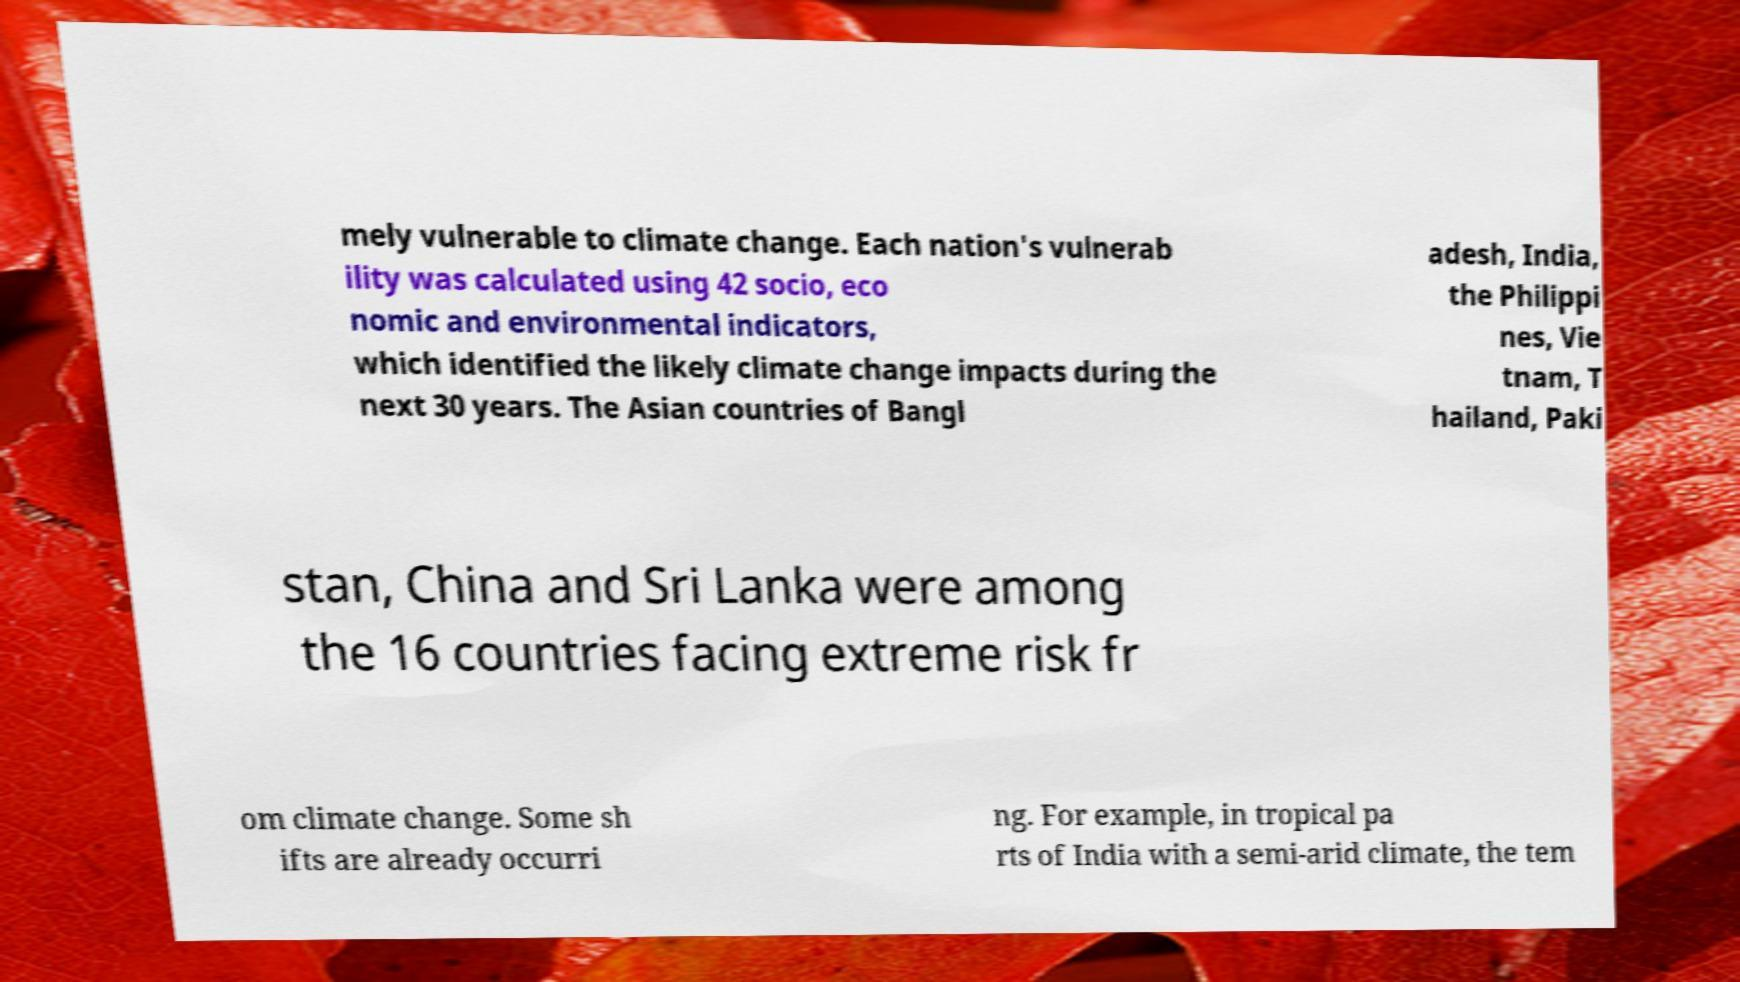For documentation purposes, I need the text within this image transcribed. Could you provide that? mely vulnerable to climate change. Each nation's vulnerab ility was calculated using 42 socio, eco nomic and environmental indicators, which identified the likely climate change impacts during the next 30 years. The Asian countries of Bangl adesh, India, the Philippi nes, Vie tnam, T hailand, Paki stan, China and Sri Lanka were among the 16 countries facing extreme risk fr om climate change. Some sh ifts are already occurri ng. For example, in tropical pa rts of India with a semi-arid climate, the tem 